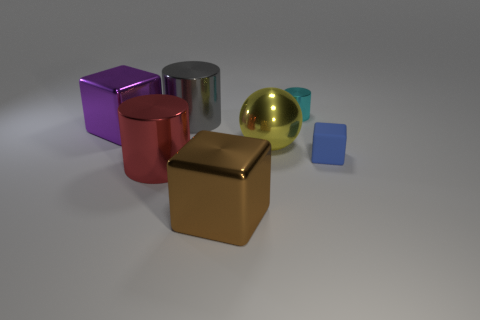There is a large metallic block left of the red thing; what color is it?
Provide a succinct answer. Purple. There is a metallic cylinder that is right of the yellow ball; is its size the same as the purple metal object?
Provide a short and direct response. No. Is there a brown rubber ball of the same size as the brown thing?
Provide a succinct answer. No. Do the small object in front of the cyan metallic cylinder and the object in front of the big red object have the same color?
Make the answer very short. No. Is there a tiny thing of the same color as the tiny shiny cylinder?
Keep it short and to the point. No. What number of other things are the same shape as the yellow thing?
Make the answer very short. 0. What shape is the tiny object that is behind the yellow metallic object?
Your response must be concise. Cylinder. There is a blue matte thing; does it have the same shape as the large object behind the purple shiny thing?
Your response must be concise. No. There is a thing that is both in front of the purple object and left of the large brown object; what size is it?
Provide a short and direct response. Large. What is the color of the metal cylinder that is behind the small blue cube and on the left side of the cyan cylinder?
Your answer should be compact. Gray. 